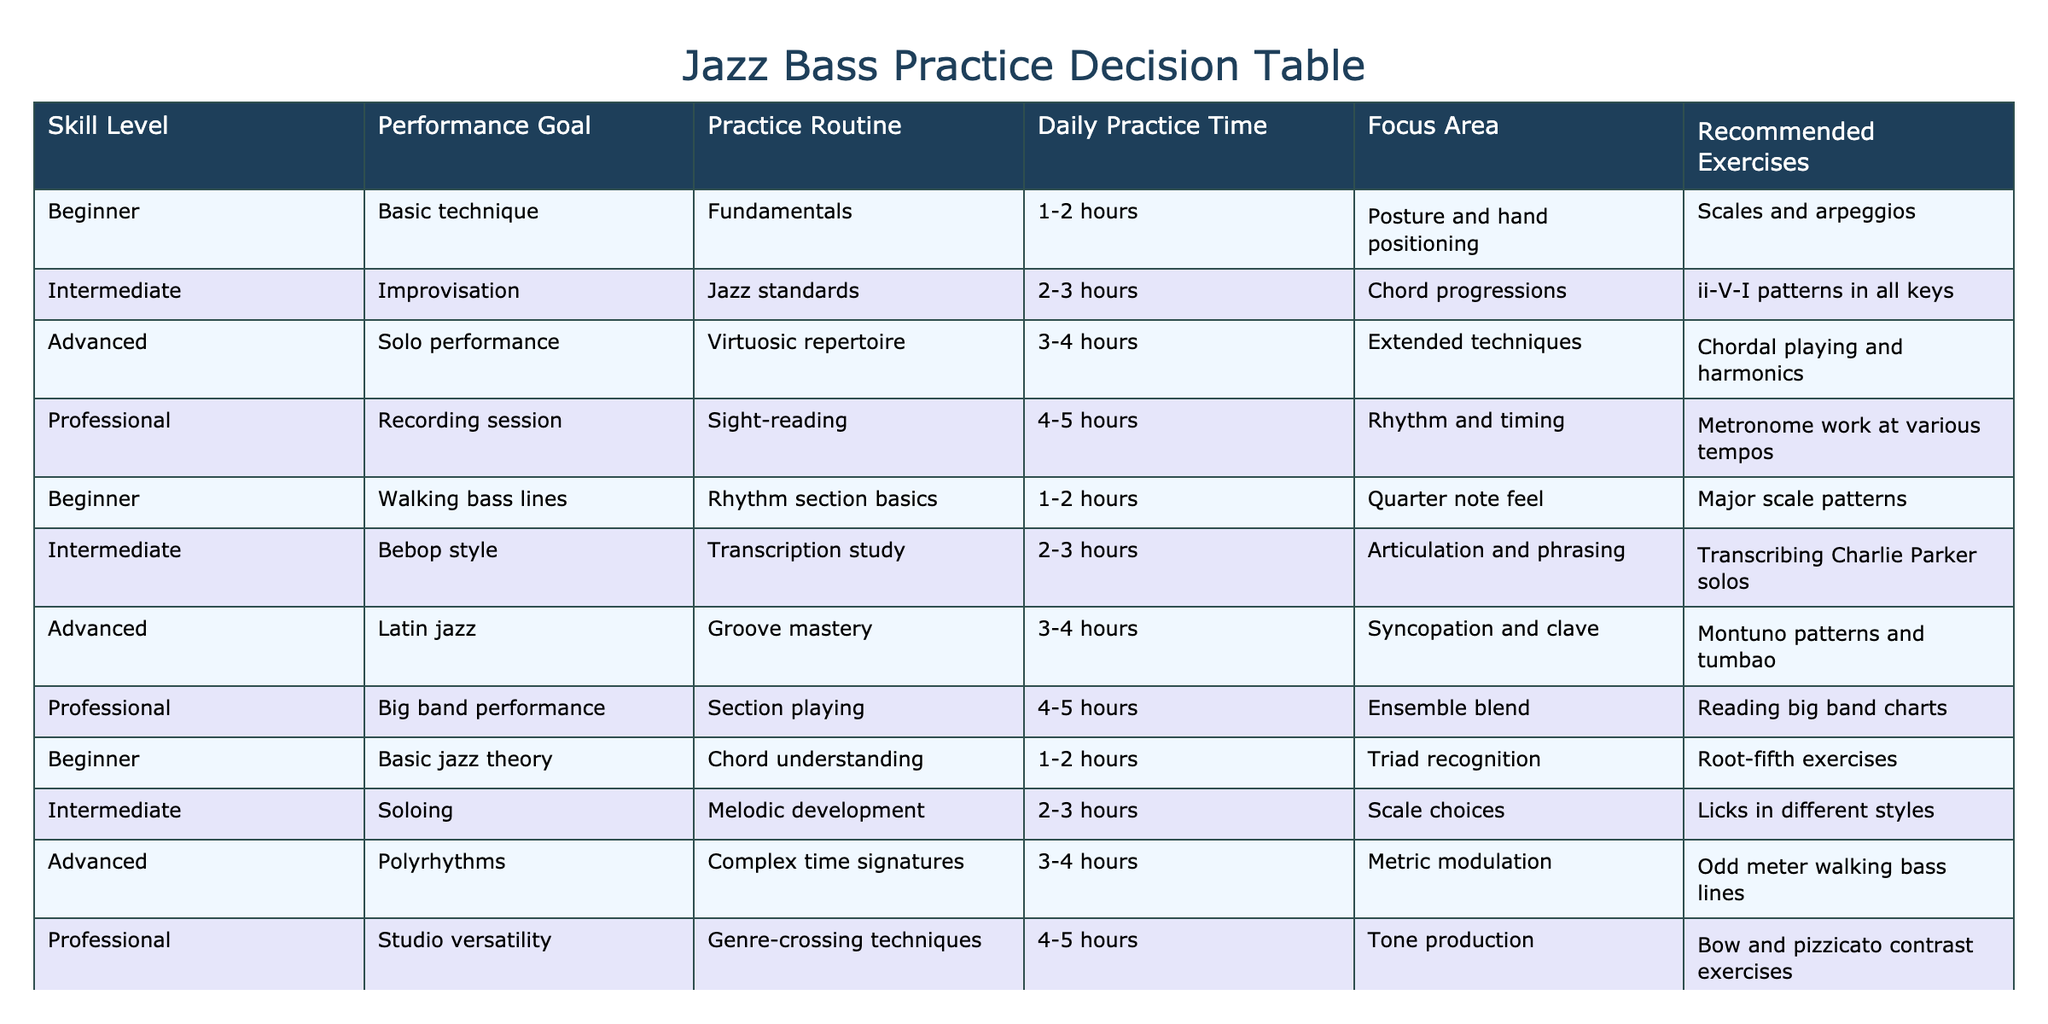What practice routine is recommended for a beginner focused on basic jazz theory? According to the table, for a beginner with a performance goal of basic jazz theory, the recommended practice routine is "Chord understanding."
Answer: Chord understanding What is the daily practice time for advanced players focusing on polyrhythms? The table indicates that advanced players focusing on polyrhythms should practice for "3-4 hours" daily.
Answer: 3-4 hours Is the recommended exercise for solo performance different from that for jazz standards? Yes, the recommended exercise for solo performance is "Chordal playing and harmonics," while for jazz standards, it is "ii-V-I patterns in all keys."
Answer: Yes What is the average daily practice time for professional players? There are two entries for professional players: 4-5 hours (sight-reading and studio versatility). The average daily practice time is calculated as (4+5+4+5)/4 = 4.5 hours.
Answer: 4.5 hours Which performance goal requires the least amount of daily practice time? Looking through the table, the performance goal of "Basic technique" for beginners and "Walking bass lines," also for beginners, both require a daily practice time of 1-2 hours, which is the least amount.
Answer: 1-2 hours Can intermediate players focusing on bebop style practice more hours than those focusing on improvisation? No, intermediate players focusing on bebop style practice for 2-3 hours, which is the same duration as those focusing on improvisation.
Answer: No What is the primary focus area for intermediate players when studying jazz standards? The primary focus area for intermediate players studying jazz standards is "Chord progressions."
Answer: Chord progressions How many different performance goals are associated with a daily practice time of 3-4 hours? There are three performance goals associated with a daily practice time of 3-4 hours: Solo performance, Latin jazz, and polyrhythms.
Answer: Three Which exercise is recommended for beginners focusing on walking bass lines? The recommended exercise for beginners focusing on walking bass lines is "Major scale patterns."
Answer: Major scale patterns 